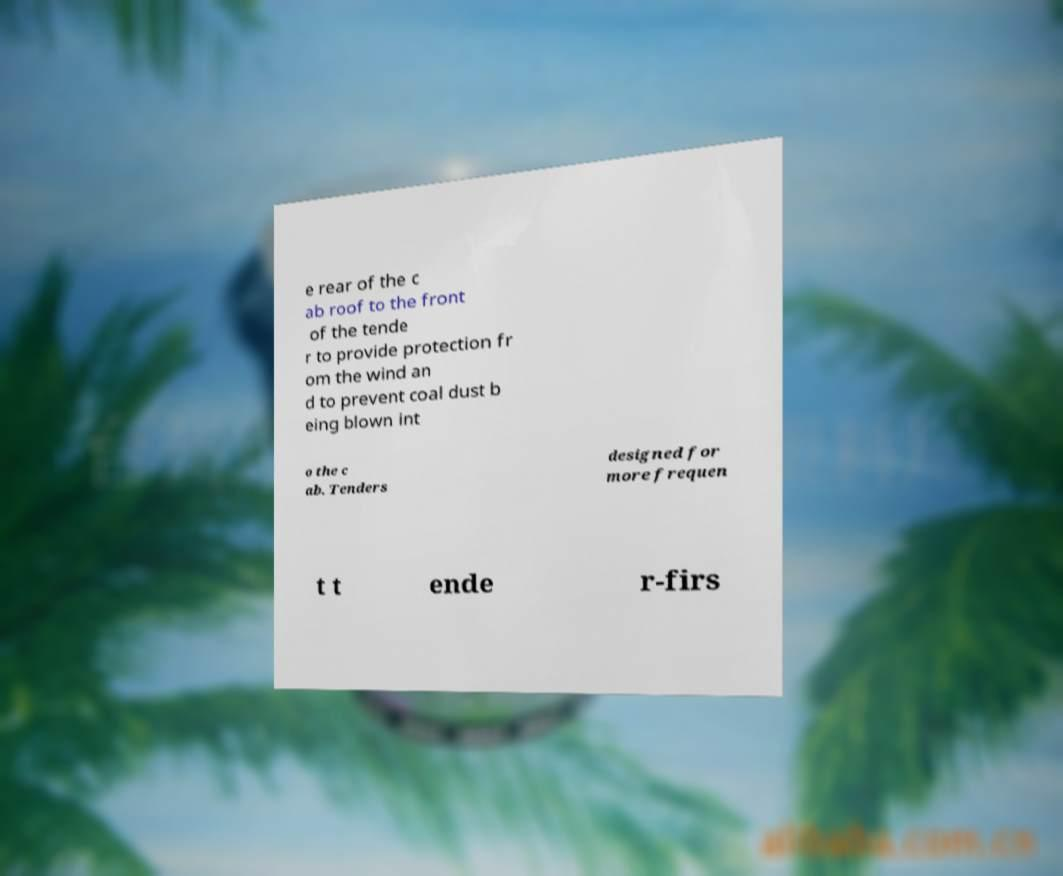There's text embedded in this image that I need extracted. Can you transcribe it verbatim? e rear of the c ab roof to the front of the tende r to provide protection fr om the wind an d to prevent coal dust b eing blown int o the c ab. Tenders designed for more frequen t t ende r-firs 